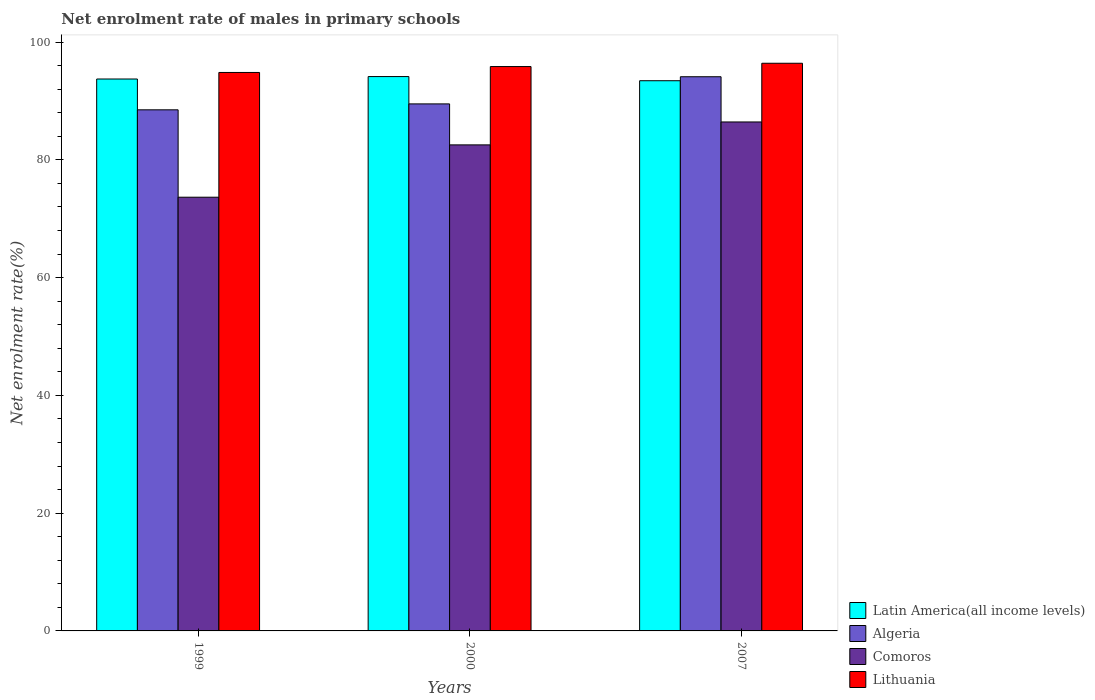How many different coloured bars are there?
Keep it short and to the point. 4. Are the number of bars per tick equal to the number of legend labels?
Provide a short and direct response. Yes. Are the number of bars on each tick of the X-axis equal?
Your response must be concise. Yes. How many bars are there on the 3rd tick from the left?
Make the answer very short. 4. How many bars are there on the 1st tick from the right?
Ensure brevity in your answer.  4. In how many cases, is the number of bars for a given year not equal to the number of legend labels?
Your answer should be compact. 0. What is the net enrolment rate of males in primary schools in Comoros in 1999?
Your answer should be compact. 73.65. Across all years, what is the maximum net enrolment rate of males in primary schools in Latin America(all income levels)?
Your response must be concise. 94.14. Across all years, what is the minimum net enrolment rate of males in primary schools in Lithuania?
Your response must be concise. 94.83. In which year was the net enrolment rate of males in primary schools in Latin America(all income levels) maximum?
Give a very brief answer. 2000. What is the total net enrolment rate of males in primary schools in Lithuania in the graph?
Your response must be concise. 287.06. What is the difference between the net enrolment rate of males in primary schools in Lithuania in 1999 and that in 2007?
Provide a short and direct response. -1.56. What is the difference between the net enrolment rate of males in primary schools in Algeria in 2000 and the net enrolment rate of males in primary schools in Lithuania in 1999?
Your response must be concise. -5.34. What is the average net enrolment rate of males in primary schools in Algeria per year?
Keep it short and to the point. 90.7. In the year 2000, what is the difference between the net enrolment rate of males in primary schools in Lithuania and net enrolment rate of males in primary schools in Algeria?
Keep it short and to the point. 6.34. What is the ratio of the net enrolment rate of males in primary schools in Lithuania in 2000 to that in 2007?
Your answer should be very brief. 0.99. Is the net enrolment rate of males in primary schools in Lithuania in 1999 less than that in 2007?
Keep it short and to the point. Yes. What is the difference between the highest and the second highest net enrolment rate of males in primary schools in Lithuania?
Keep it short and to the point. 0.56. What is the difference between the highest and the lowest net enrolment rate of males in primary schools in Latin America(all income levels)?
Offer a terse response. 0.71. In how many years, is the net enrolment rate of males in primary schools in Algeria greater than the average net enrolment rate of males in primary schools in Algeria taken over all years?
Your answer should be very brief. 1. Is it the case that in every year, the sum of the net enrolment rate of males in primary schools in Algeria and net enrolment rate of males in primary schools in Comoros is greater than the sum of net enrolment rate of males in primary schools in Latin America(all income levels) and net enrolment rate of males in primary schools in Lithuania?
Your response must be concise. No. What does the 3rd bar from the left in 2007 represents?
Provide a short and direct response. Comoros. What does the 2nd bar from the right in 2000 represents?
Your answer should be very brief. Comoros. Are all the bars in the graph horizontal?
Offer a very short reply. No. How many years are there in the graph?
Offer a terse response. 3. Does the graph contain any zero values?
Your answer should be compact. No. Does the graph contain grids?
Offer a terse response. No. Where does the legend appear in the graph?
Provide a succinct answer. Bottom right. How many legend labels are there?
Your answer should be very brief. 4. How are the legend labels stacked?
Your answer should be very brief. Vertical. What is the title of the graph?
Provide a succinct answer. Net enrolment rate of males in primary schools. What is the label or title of the Y-axis?
Offer a very short reply. Net enrolment rate(%). What is the Net enrolment rate(%) of Latin America(all income levels) in 1999?
Your answer should be compact. 93.72. What is the Net enrolment rate(%) of Algeria in 1999?
Give a very brief answer. 88.49. What is the Net enrolment rate(%) in Comoros in 1999?
Your response must be concise. 73.65. What is the Net enrolment rate(%) of Lithuania in 1999?
Your answer should be compact. 94.83. What is the Net enrolment rate(%) of Latin America(all income levels) in 2000?
Ensure brevity in your answer.  94.14. What is the Net enrolment rate(%) of Algeria in 2000?
Provide a short and direct response. 89.49. What is the Net enrolment rate(%) of Comoros in 2000?
Offer a terse response. 82.53. What is the Net enrolment rate(%) in Lithuania in 2000?
Offer a terse response. 95.83. What is the Net enrolment rate(%) of Latin America(all income levels) in 2007?
Your answer should be compact. 93.43. What is the Net enrolment rate(%) in Algeria in 2007?
Your response must be concise. 94.11. What is the Net enrolment rate(%) of Comoros in 2007?
Offer a very short reply. 86.43. What is the Net enrolment rate(%) in Lithuania in 2007?
Your response must be concise. 96.4. Across all years, what is the maximum Net enrolment rate(%) of Latin America(all income levels)?
Offer a very short reply. 94.14. Across all years, what is the maximum Net enrolment rate(%) in Algeria?
Your response must be concise. 94.11. Across all years, what is the maximum Net enrolment rate(%) of Comoros?
Give a very brief answer. 86.43. Across all years, what is the maximum Net enrolment rate(%) of Lithuania?
Keep it short and to the point. 96.4. Across all years, what is the minimum Net enrolment rate(%) in Latin America(all income levels)?
Keep it short and to the point. 93.43. Across all years, what is the minimum Net enrolment rate(%) in Algeria?
Your response must be concise. 88.49. Across all years, what is the minimum Net enrolment rate(%) in Comoros?
Offer a very short reply. 73.65. Across all years, what is the minimum Net enrolment rate(%) in Lithuania?
Offer a terse response. 94.83. What is the total Net enrolment rate(%) of Latin America(all income levels) in the graph?
Provide a succinct answer. 281.29. What is the total Net enrolment rate(%) of Algeria in the graph?
Your response must be concise. 272.09. What is the total Net enrolment rate(%) of Comoros in the graph?
Give a very brief answer. 242.61. What is the total Net enrolment rate(%) in Lithuania in the graph?
Ensure brevity in your answer.  287.06. What is the difference between the Net enrolment rate(%) in Latin America(all income levels) in 1999 and that in 2000?
Make the answer very short. -0.42. What is the difference between the Net enrolment rate(%) in Algeria in 1999 and that in 2000?
Your response must be concise. -1. What is the difference between the Net enrolment rate(%) of Comoros in 1999 and that in 2000?
Your answer should be very brief. -8.89. What is the difference between the Net enrolment rate(%) in Lithuania in 1999 and that in 2000?
Ensure brevity in your answer.  -1. What is the difference between the Net enrolment rate(%) of Latin America(all income levels) in 1999 and that in 2007?
Provide a short and direct response. 0.29. What is the difference between the Net enrolment rate(%) in Algeria in 1999 and that in 2007?
Offer a terse response. -5.62. What is the difference between the Net enrolment rate(%) in Comoros in 1999 and that in 2007?
Give a very brief answer. -12.78. What is the difference between the Net enrolment rate(%) in Lithuania in 1999 and that in 2007?
Your answer should be very brief. -1.56. What is the difference between the Net enrolment rate(%) in Latin America(all income levels) in 2000 and that in 2007?
Provide a short and direct response. 0.71. What is the difference between the Net enrolment rate(%) in Algeria in 2000 and that in 2007?
Your response must be concise. -4.61. What is the difference between the Net enrolment rate(%) of Comoros in 2000 and that in 2007?
Offer a terse response. -3.89. What is the difference between the Net enrolment rate(%) in Lithuania in 2000 and that in 2007?
Provide a short and direct response. -0.56. What is the difference between the Net enrolment rate(%) of Latin America(all income levels) in 1999 and the Net enrolment rate(%) of Algeria in 2000?
Provide a succinct answer. 4.23. What is the difference between the Net enrolment rate(%) of Latin America(all income levels) in 1999 and the Net enrolment rate(%) of Comoros in 2000?
Offer a very short reply. 11.19. What is the difference between the Net enrolment rate(%) in Latin America(all income levels) in 1999 and the Net enrolment rate(%) in Lithuania in 2000?
Offer a very short reply. -2.12. What is the difference between the Net enrolment rate(%) in Algeria in 1999 and the Net enrolment rate(%) in Comoros in 2000?
Your answer should be compact. 5.96. What is the difference between the Net enrolment rate(%) in Algeria in 1999 and the Net enrolment rate(%) in Lithuania in 2000?
Your answer should be very brief. -7.35. What is the difference between the Net enrolment rate(%) of Comoros in 1999 and the Net enrolment rate(%) of Lithuania in 2000?
Provide a short and direct response. -22.19. What is the difference between the Net enrolment rate(%) of Latin America(all income levels) in 1999 and the Net enrolment rate(%) of Algeria in 2007?
Make the answer very short. -0.39. What is the difference between the Net enrolment rate(%) in Latin America(all income levels) in 1999 and the Net enrolment rate(%) in Comoros in 2007?
Ensure brevity in your answer.  7.29. What is the difference between the Net enrolment rate(%) of Latin America(all income levels) in 1999 and the Net enrolment rate(%) of Lithuania in 2007?
Provide a succinct answer. -2.68. What is the difference between the Net enrolment rate(%) in Algeria in 1999 and the Net enrolment rate(%) in Comoros in 2007?
Offer a very short reply. 2.06. What is the difference between the Net enrolment rate(%) in Algeria in 1999 and the Net enrolment rate(%) in Lithuania in 2007?
Your answer should be compact. -7.91. What is the difference between the Net enrolment rate(%) of Comoros in 1999 and the Net enrolment rate(%) of Lithuania in 2007?
Provide a short and direct response. -22.75. What is the difference between the Net enrolment rate(%) of Latin America(all income levels) in 2000 and the Net enrolment rate(%) of Algeria in 2007?
Provide a succinct answer. 0.03. What is the difference between the Net enrolment rate(%) of Latin America(all income levels) in 2000 and the Net enrolment rate(%) of Comoros in 2007?
Provide a succinct answer. 7.71. What is the difference between the Net enrolment rate(%) of Latin America(all income levels) in 2000 and the Net enrolment rate(%) of Lithuania in 2007?
Make the answer very short. -2.26. What is the difference between the Net enrolment rate(%) of Algeria in 2000 and the Net enrolment rate(%) of Comoros in 2007?
Provide a short and direct response. 3.07. What is the difference between the Net enrolment rate(%) of Algeria in 2000 and the Net enrolment rate(%) of Lithuania in 2007?
Your answer should be compact. -6.9. What is the difference between the Net enrolment rate(%) of Comoros in 2000 and the Net enrolment rate(%) of Lithuania in 2007?
Provide a succinct answer. -13.86. What is the average Net enrolment rate(%) in Latin America(all income levels) per year?
Offer a very short reply. 93.76. What is the average Net enrolment rate(%) in Algeria per year?
Your response must be concise. 90.7. What is the average Net enrolment rate(%) in Comoros per year?
Give a very brief answer. 80.87. What is the average Net enrolment rate(%) of Lithuania per year?
Your answer should be very brief. 95.69. In the year 1999, what is the difference between the Net enrolment rate(%) in Latin America(all income levels) and Net enrolment rate(%) in Algeria?
Your answer should be very brief. 5.23. In the year 1999, what is the difference between the Net enrolment rate(%) in Latin America(all income levels) and Net enrolment rate(%) in Comoros?
Keep it short and to the point. 20.07. In the year 1999, what is the difference between the Net enrolment rate(%) of Latin America(all income levels) and Net enrolment rate(%) of Lithuania?
Keep it short and to the point. -1.11. In the year 1999, what is the difference between the Net enrolment rate(%) of Algeria and Net enrolment rate(%) of Comoros?
Offer a terse response. 14.84. In the year 1999, what is the difference between the Net enrolment rate(%) of Algeria and Net enrolment rate(%) of Lithuania?
Provide a short and direct response. -6.34. In the year 1999, what is the difference between the Net enrolment rate(%) in Comoros and Net enrolment rate(%) in Lithuania?
Ensure brevity in your answer.  -21.18. In the year 2000, what is the difference between the Net enrolment rate(%) of Latin America(all income levels) and Net enrolment rate(%) of Algeria?
Your answer should be compact. 4.64. In the year 2000, what is the difference between the Net enrolment rate(%) of Latin America(all income levels) and Net enrolment rate(%) of Comoros?
Give a very brief answer. 11.6. In the year 2000, what is the difference between the Net enrolment rate(%) of Latin America(all income levels) and Net enrolment rate(%) of Lithuania?
Provide a short and direct response. -1.7. In the year 2000, what is the difference between the Net enrolment rate(%) of Algeria and Net enrolment rate(%) of Comoros?
Make the answer very short. 6.96. In the year 2000, what is the difference between the Net enrolment rate(%) in Algeria and Net enrolment rate(%) in Lithuania?
Offer a very short reply. -6.34. In the year 2000, what is the difference between the Net enrolment rate(%) of Comoros and Net enrolment rate(%) of Lithuania?
Provide a short and direct response. -13.3. In the year 2007, what is the difference between the Net enrolment rate(%) in Latin America(all income levels) and Net enrolment rate(%) in Algeria?
Offer a very short reply. -0.68. In the year 2007, what is the difference between the Net enrolment rate(%) in Latin America(all income levels) and Net enrolment rate(%) in Comoros?
Make the answer very short. 7. In the year 2007, what is the difference between the Net enrolment rate(%) of Latin America(all income levels) and Net enrolment rate(%) of Lithuania?
Your response must be concise. -2.97. In the year 2007, what is the difference between the Net enrolment rate(%) of Algeria and Net enrolment rate(%) of Comoros?
Your answer should be very brief. 7.68. In the year 2007, what is the difference between the Net enrolment rate(%) of Algeria and Net enrolment rate(%) of Lithuania?
Keep it short and to the point. -2.29. In the year 2007, what is the difference between the Net enrolment rate(%) in Comoros and Net enrolment rate(%) in Lithuania?
Provide a short and direct response. -9.97. What is the ratio of the Net enrolment rate(%) of Latin America(all income levels) in 1999 to that in 2000?
Provide a succinct answer. 1. What is the ratio of the Net enrolment rate(%) in Comoros in 1999 to that in 2000?
Provide a short and direct response. 0.89. What is the ratio of the Net enrolment rate(%) in Lithuania in 1999 to that in 2000?
Provide a short and direct response. 0.99. What is the ratio of the Net enrolment rate(%) in Latin America(all income levels) in 1999 to that in 2007?
Keep it short and to the point. 1. What is the ratio of the Net enrolment rate(%) in Algeria in 1999 to that in 2007?
Your answer should be very brief. 0.94. What is the ratio of the Net enrolment rate(%) of Comoros in 1999 to that in 2007?
Offer a terse response. 0.85. What is the ratio of the Net enrolment rate(%) in Lithuania in 1999 to that in 2007?
Ensure brevity in your answer.  0.98. What is the ratio of the Net enrolment rate(%) of Latin America(all income levels) in 2000 to that in 2007?
Make the answer very short. 1.01. What is the ratio of the Net enrolment rate(%) in Algeria in 2000 to that in 2007?
Provide a succinct answer. 0.95. What is the ratio of the Net enrolment rate(%) of Comoros in 2000 to that in 2007?
Provide a short and direct response. 0.95. What is the ratio of the Net enrolment rate(%) of Lithuania in 2000 to that in 2007?
Offer a very short reply. 0.99. What is the difference between the highest and the second highest Net enrolment rate(%) of Latin America(all income levels)?
Your answer should be compact. 0.42. What is the difference between the highest and the second highest Net enrolment rate(%) in Algeria?
Your answer should be compact. 4.61. What is the difference between the highest and the second highest Net enrolment rate(%) of Comoros?
Provide a short and direct response. 3.89. What is the difference between the highest and the second highest Net enrolment rate(%) of Lithuania?
Ensure brevity in your answer.  0.56. What is the difference between the highest and the lowest Net enrolment rate(%) in Latin America(all income levels)?
Offer a very short reply. 0.71. What is the difference between the highest and the lowest Net enrolment rate(%) in Algeria?
Make the answer very short. 5.62. What is the difference between the highest and the lowest Net enrolment rate(%) in Comoros?
Your answer should be compact. 12.78. What is the difference between the highest and the lowest Net enrolment rate(%) in Lithuania?
Offer a terse response. 1.56. 